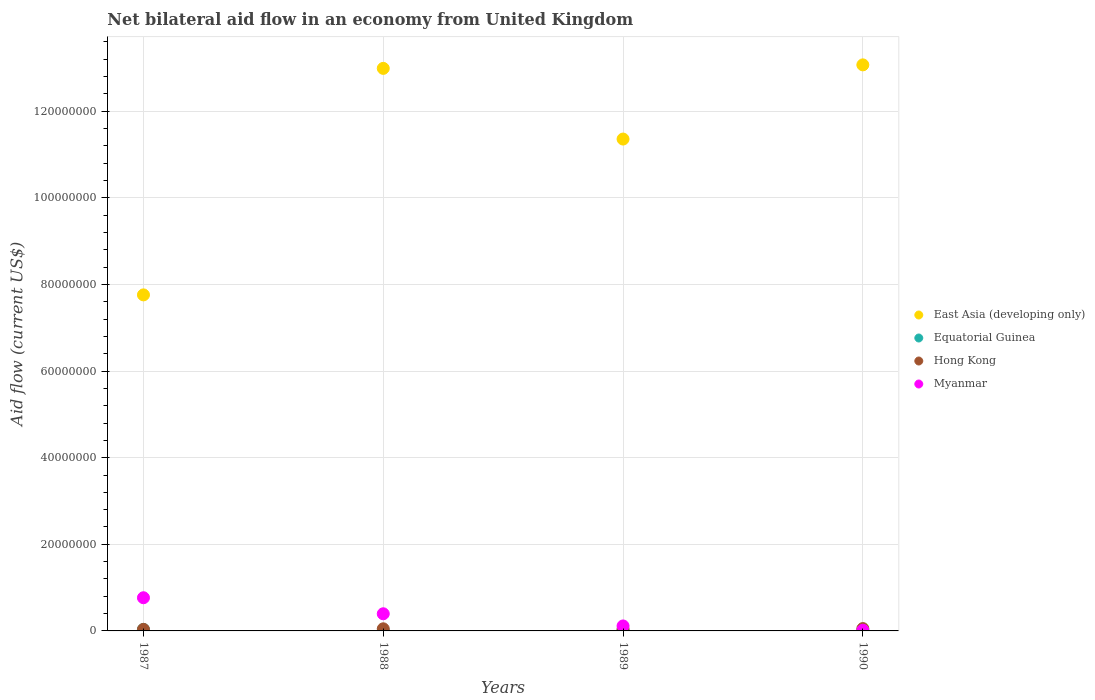How many different coloured dotlines are there?
Your answer should be compact. 4. Is the number of dotlines equal to the number of legend labels?
Ensure brevity in your answer.  Yes. What is the net bilateral aid flow in Hong Kong in 1988?
Provide a succinct answer. 4.90e+05. In which year was the net bilateral aid flow in Equatorial Guinea maximum?
Your answer should be very brief. 1987. In which year was the net bilateral aid flow in Myanmar minimum?
Your answer should be compact. 1990. What is the total net bilateral aid flow in Hong Kong in the graph?
Offer a terse response. 1.79e+06. What is the difference between the net bilateral aid flow in Hong Kong in 1988 and that in 1990?
Offer a very short reply. -5.00e+04. What is the difference between the net bilateral aid flow in Equatorial Guinea in 1989 and the net bilateral aid flow in Myanmar in 1987?
Offer a very short reply. -7.52e+06. What is the average net bilateral aid flow in Hong Kong per year?
Keep it short and to the point. 4.48e+05. In the year 1987, what is the difference between the net bilateral aid flow in Equatorial Guinea and net bilateral aid flow in East Asia (developing only)?
Provide a succinct answer. -7.72e+07. What is the ratio of the net bilateral aid flow in Hong Kong in 1987 to that in 1989?
Provide a succinct answer. 0.9. What is the difference between the highest and the lowest net bilateral aid flow in Myanmar?
Offer a terse response. 7.50e+06. Does the net bilateral aid flow in Myanmar monotonically increase over the years?
Your answer should be compact. No. Are the values on the major ticks of Y-axis written in scientific E-notation?
Your response must be concise. No. How are the legend labels stacked?
Keep it short and to the point. Vertical. What is the title of the graph?
Give a very brief answer. Net bilateral aid flow in an economy from United Kingdom. What is the label or title of the Y-axis?
Your answer should be compact. Aid flow (current US$). What is the Aid flow (current US$) in East Asia (developing only) in 1987?
Your answer should be compact. 7.76e+07. What is the Aid flow (current US$) of Hong Kong in 1987?
Your answer should be very brief. 3.60e+05. What is the Aid flow (current US$) of Myanmar in 1987?
Offer a terse response. 7.66e+06. What is the Aid flow (current US$) in East Asia (developing only) in 1988?
Offer a terse response. 1.30e+08. What is the Aid flow (current US$) of Myanmar in 1988?
Provide a succinct answer. 3.96e+06. What is the Aid flow (current US$) of East Asia (developing only) in 1989?
Your response must be concise. 1.14e+08. What is the Aid flow (current US$) in Hong Kong in 1989?
Provide a short and direct response. 4.00e+05. What is the Aid flow (current US$) of Myanmar in 1989?
Give a very brief answer. 1.15e+06. What is the Aid flow (current US$) in East Asia (developing only) in 1990?
Your response must be concise. 1.31e+08. What is the Aid flow (current US$) of Equatorial Guinea in 1990?
Keep it short and to the point. 9.00e+04. What is the Aid flow (current US$) in Hong Kong in 1990?
Offer a terse response. 5.40e+05. Across all years, what is the maximum Aid flow (current US$) in East Asia (developing only)?
Provide a succinct answer. 1.31e+08. Across all years, what is the maximum Aid flow (current US$) in Hong Kong?
Make the answer very short. 5.40e+05. Across all years, what is the maximum Aid flow (current US$) in Myanmar?
Offer a very short reply. 7.66e+06. Across all years, what is the minimum Aid flow (current US$) in East Asia (developing only)?
Give a very brief answer. 7.76e+07. Across all years, what is the minimum Aid flow (current US$) of Myanmar?
Your response must be concise. 1.60e+05. What is the total Aid flow (current US$) of East Asia (developing only) in the graph?
Offer a terse response. 4.52e+08. What is the total Aid flow (current US$) of Hong Kong in the graph?
Your answer should be compact. 1.79e+06. What is the total Aid flow (current US$) of Myanmar in the graph?
Keep it short and to the point. 1.29e+07. What is the difference between the Aid flow (current US$) in East Asia (developing only) in 1987 and that in 1988?
Your response must be concise. -5.23e+07. What is the difference between the Aid flow (current US$) of Equatorial Guinea in 1987 and that in 1988?
Provide a succinct answer. 3.10e+05. What is the difference between the Aid flow (current US$) of Myanmar in 1987 and that in 1988?
Your answer should be compact. 3.70e+06. What is the difference between the Aid flow (current US$) of East Asia (developing only) in 1987 and that in 1989?
Offer a very short reply. -3.60e+07. What is the difference between the Aid flow (current US$) of Equatorial Guinea in 1987 and that in 1989?
Make the answer very short. 2.00e+05. What is the difference between the Aid flow (current US$) in Myanmar in 1987 and that in 1989?
Give a very brief answer. 6.51e+06. What is the difference between the Aid flow (current US$) in East Asia (developing only) in 1987 and that in 1990?
Your answer should be compact. -5.31e+07. What is the difference between the Aid flow (current US$) of Equatorial Guinea in 1987 and that in 1990?
Your answer should be very brief. 2.50e+05. What is the difference between the Aid flow (current US$) of Hong Kong in 1987 and that in 1990?
Provide a succinct answer. -1.80e+05. What is the difference between the Aid flow (current US$) of Myanmar in 1987 and that in 1990?
Ensure brevity in your answer.  7.50e+06. What is the difference between the Aid flow (current US$) in East Asia (developing only) in 1988 and that in 1989?
Give a very brief answer. 1.63e+07. What is the difference between the Aid flow (current US$) of Equatorial Guinea in 1988 and that in 1989?
Give a very brief answer. -1.10e+05. What is the difference between the Aid flow (current US$) in Myanmar in 1988 and that in 1989?
Offer a very short reply. 2.81e+06. What is the difference between the Aid flow (current US$) in East Asia (developing only) in 1988 and that in 1990?
Ensure brevity in your answer.  -8.10e+05. What is the difference between the Aid flow (current US$) in Equatorial Guinea in 1988 and that in 1990?
Your answer should be very brief. -6.00e+04. What is the difference between the Aid flow (current US$) of Hong Kong in 1988 and that in 1990?
Ensure brevity in your answer.  -5.00e+04. What is the difference between the Aid flow (current US$) in Myanmar in 1988 and that in 1990?
Offer a terse response. 3.80e+06. What is the difference between the Aid flow (current US$) of East Asia (developing only) in 1989 and that in 1990?
Ensure brevity in your answer.  -1.71e+07. What is the difference between the Aid flow (current US$) in Equatorial Guinea in 1989 and that in 1990?
Offer a very short reply. 5.00e+04. What is the difference between the Aid flow (current US$) of Hong Kong in 1989 and that in 1990?
Your response must be concise. -1.40e+05. What is the difference between the Aid flow (current US$) of Myanmar in 1989 and that in 1990?
Your answer should be compact. 9.90e+05. What is the difference between the Aid flow (current US$) of East Asia (developing only) in 1987 and the Aid flow (current US$) of Equatorial Guinea in 1988?
Ensure brevity in your answer.  7.76e+07. What is the difference between the Aid flow (current US$) of East Asia (developing only) in 1987 and the Aid flow (current US$) of Hong Kong in 1988?
Provide a succinct answer. 7.71e+07. What is the difference between the Aid flow (current US$) in East Asia (developing only) in 1987 and the Aid flow (current US$) in Myanmar in 1988?
Offer a terse response. 7.36e+07. What is the difference between the Aid flow (current US$) in Equatorial Guinea in 1987 and the Aid flow (current US$) in Myanmar in 1988?
Make the answer very short. -3.62e+06. What is the difference between the Aid flow (current US$) of Hong Kong in 1987 and the Aid flow (current US$) of Myanmar in 1988?
Offer a terse response. -3.60e+06. What is the difference between the Aid flow (current US$) in East Asia (developing only) in 1987 and the Aid flow (current US$) in Equatorial Guinea in 1989?
Make the answer very short. 7.74e+07. What is the difference between the Aid flow (current US$) in East Asia (developing only) in 1987 and the Aid flow (current US$) in Hong Kong in 1989?
Keep it short and to the point. 7.72e+07. What is the difference between the Aid flow (current US$) in East Asia (developing only) in 1987 and the Aid flow (current US$) in Myanmar in 1989?
Offer a terse response. 7.64e+07. What is the difference between the Aid flow (current US$) in Equatorial Guinea in 1987 and the Aid flow (current US$) in Hong Kong in 1989?
Provide a short and direct response. -6.00e+04. What is the difference between the Aid flow (current US$) of Equatorial Guinea in 1987 and the Aid flow (current US$) of Myanmar in 1989?
Offer a terse response. -8.10e+05. What is the difference between the Aid flow (current US$) of Hong Kong in 1987 and the Aid flow (current US$) of Myanmar in 1989?
Offer a very short reply. -7.90e+05. What is the difference between the Aid flow (current US$) of East Asia (developing only) in 1987 and the Aid flow (current US$) of Equatorial Guinea in 1990?
Your response must be concise. 7.75e+07. What is the difference between the Aid flow (current US$) in East Asia (developing only) in 1987 and the Aid flow (current US$) in Hong Kong in 1990?
Make the answer very short. 7.70e+07. What is the difference between the Aid flow (current US$) in East Asia (developing only) in 1987 and the Aid flow (current US$) in Myanmar in 1990?
Your answer should be compact. 7.74e+07. What is the difference between the Aid flow (current US$) in East Asia (developing only) in 1988 and the Aid flow (current US$) in Equatorial Guinea in 1989?
Ensure brevity in your answer.  1.30e+08. What is the difference between the Aid flow (current US$) in East Asia (developing only) in 1988 and the Aid flow (current US$) in Hong Kong in 1989?
Your answer should be compact. 1.29e+08. What is the difference between the Aid flow (current US$) of East Asia (developing only) in 1988 and the Aid flow (current US$) of Myanmar in 1989?
Keep it short and to the point. 1.29e+08. What is the difference between the Aid flow (current US$) of Equatorial Guinea in 1988 and the Aid flow (current US$) of Hong Kong in 1989?
Keep it short and to the point. -3.70e+05. What is the difference between the Aid flow (current US$) of Equatorial Guinea in 1988 and the Aid flow (current US$) of Myanmar in 1989?
Keep it short and to the point. -1.12e+06. What is the difference between the Aid flow (current US$) in Hong Kong in 1988 and the Aid flow (current US$) in Myanmar in 1989?
Offer a terse response. -6.60e+05. What is the difference between the Aid flow (current US$) of East Asia (developing only) in 1988 and the Aid flow (current US$) of Equatorial Guinea in 1990?
Your answer should be very brief. 1.30e+08. What is the difference between the Aid flow (current US$) of East Asia (developing only) in 1988 and the Aid flow (current US$) of Hong Kong in 1990?
Provide a succinct answer. 1.29e+08. What is the difference between the Aid flow (current US$) in East Asia (developing only) in 1988 and the Aid flow (current US$) in Myanmar in 1990?
Offer a very short reply. 1.30e+08. What is the difference between the Aid flow (current US$) in Equatorial Guinea in 1988 and the Aid flow (current US$) in Hong Kong in 1990?
Offer a very short reply. -5.10e+05. What is the difference between the Aid flow (current US$) in Hong Kong in 1988 and the Aid flow (current US$) in Myanmar in 1990?
Keep it short and to the point. 3.30e+05. What is the difference between the Aid flow (current US$) in East Asia (developing only) in 1989 and the Aid flow (current US$) in Equatorial Guinea in 1990?
Make the answer very short. 1.13e+08. What is the difference between the Aid flow (current US$) in East Asia (developing only) in 1989 and the Aid flow (current US$) in Hong Kong in 1990?
Provide a short and direct response. 1.13e+08. What is the difference between the Aid flow (current US$) of East Asia (developing only) in 1989 and the Aid flow (current US$) of Myanmar in 1990?
Provide a short and direct response. 1.13e+08. What is the difference between the Aid flow (current US$) of Equatorial Guinea in 1989 and the Aid flow (current US$) of Hong Kong in 1990?
Your response must be concise. -4.00e+05. What is the difference between the Aid flow (current US$) in Hong Kong in 1989 and the Aid flow (current US$) in Myanmar in 1990?
Make the answer very short. 2.40e+05. What is the average Aid flow (current US$) in East Asia (developing only) per year?
Your answer should be very brief. 1.13e+08. What is the average Aid flow (current US$) of Hong Kong per year?
Offer a terse response. 4.48e+05. What is the average Aid flow (current US$) of Myanmar per year?
Ensure brevity in your answer.  3.23e+06. In the year 1987, what is the difference between the Aid flow (current US$) of East Asia (developing only) and Aid flow (current US$) of Equatorial Guinea?
Your response must be concise. 7.72e+07. In the year 1987, what is the difference between the Aid flow (current US$) in East Asia (developing only) and Aid flow (current US$) in Hong Kong?
Your answer should be compact. 7.72e+07. In the year 1987, what is the difference between the Aid flow (current US$) in East Asia (developing only) and Aid flow (current US$) in Myanmar?
Give a very brief answer. 6.99e+07. In the year 1987, what is the difference between the Aid flow (current US$) of Equatorial Guinea and Aid flow (current US$) of Hong Kong?
Provide a succinct answer. -2.00e+04. In the year 1987, what is the difference between the Aid flow (current US$) in Equatorial Guinea and Aid flow (current US$) in Myanmar?
Offer a very short reply. -7.32e+06. In the year 1987, what is the difference between the Aid flow (current US$) in Hong Kong and Aid flow (current US$) in Myanmar?
Keep it short and to the point. -7.30e+06. In the year 1988, what is the difference between the Aid flow (current US$) in East Asia (developing only) and Aid flow (current US$) in Equatorial Guinea?
Provide a short and direct response. 1.30e+08. In the year 1988, what is the difference between the Aid flow (current US$) in East Asia (developing only) and Aid flow (current US$) in Hong Kong?
Keep it short and to the point. 1.29e+08. In the year 1988, what is the difference between the Aid flow (current US$) of East Asia (developing only) and Aid flow (current US$) of Myanmar?
Ensure brevity in your answer.  1.26e+08. In the year 1988, what is the difference between the Aid flow (current US$) of Equatorial Guinea and Aid flow (current US$) of Hong Kong?
Offer a very short reply. -4.60e+05. In the year 1988, what is the difference between the Aid flow (current US$) of Equatorial Guinea and Aid flow (current US$) of Myanmar?
Make the answer very short. -3.93e+06. In the year 1988, what is the difference between the Aid flow (current US$) in Hong Kong and Aid flow (current US$) in Myanmar?
Your answer should be very brief. -3.47e+06. In the year 1989, what is the difference between the Aid flow (current US$) in East Asia (developing only) and Aid flow (current US$) in Equatorial Guinea?
Offer a very short reply. 1.13e+08. In the year 1989, what is the difference between the Aid flow (current US$) in East Asia (developing only) and Aid flow (current US$) in Hong Kong?
Offer a terse response. 1.13e+08. In the year 1989, what is the difference between the Aid flow (current US$) in East Asia (developing only) and Aid flow (current US$) in Myanmar?
Provide a succinct answer. 1.12e+08. In the year 1989, what is the difference between the Aid flow (current US$) of Equatorial Guinea and Aid flow (current US$) of Myanmar?
Provide a short and direct response. -1.01e+06. In the year 1989, what is the difference between the Aid flow (current US$) of Hong Kong and Aid flow (current US$) of Myanmar?
Your response must be concise. -7.50e+05. In the year 1990, what is the difference between the Aid flow (current US$) in East Asia (developing only) and Aid flow (current US$) in Equatorial Guinea?
Your answer should be very brief. 1.31e+08. In the year 1990, what is the difference between the Aid flow (current US$) in East Asia (developing only) and Aid flow (current US$) in Hong Kong?
Your answer should be compact. 1.30e+08. In the year 1990, what is the difference between the Aid flow (current US$) in East Asia (developing only) and Aid flow (current US$) in Myanmar?
Offer a very short reply. 1.31e+08. In the year 1990, what is the difference between the Aid flow (current US$) in Equatorial Guinea and Aid flow (current US$) in Hong Kong?
Keep it short and to the point. -4.50e+05. What is the ratio of the Aid flow (current US$) in East Asia (developing only) in 1987 to that in 1988?
Your answer should be very brief. 0.6. What is the ratio of the Aid flow (current US$) of Equatorial Guinea in 1987 to that in 1988?
Your response must be concise. 11.33. What is the ratio of the Aid flow (current US$) of Hong Kong in 1987 to that in 1988?
Give a very brief answer. 0.73. What is the ratio of the Aid flow (current US$) in Myanmar in 1987 to that in 1988?
Your answer should be compact. 1.93. What is the ratio of the Aid flow (current US$) in East Asia (developing only) in 1987 to that in 1989?
Offer a terse response. 0.68. What is the ratio of the Aid flow (current US$) in Equatorial Guinea in 1987 to that in 1989?
Provide a short and direct response. 2.43. What is the ratio of the Aid flow (current US$) in Hong Kong in 1987 to that in 1989?
Your answer should be very brief. 0.9. What is the ratio of the Aid flow (current US$) of Myanmar in 1987 to that in 1989?
Your answer should be compact. 6.66. What is the ratio of the Aid flow (current US$) in East Asia (developing only) in 1987 to that in 1990?
Your answer should be very brief. 0.59. What is the ratio of the Aid flow (current US$) in Equatorial Guinea in 1987 to that in 1990?
Ensure brevity in your answer.  3.78. What is the ratio of the Aid flow (current US$) of Hong Kong in 1987 to that in 1990?
Keep it short and to the point. 0.67. What is the ratio of the Aid flow (current US$) in Myanmar in 1987 to that in 1990?
Offer a very short reply. 47.88. What is the ratio of the Aid flow (current US$) in East Asia (developing only) in 1988 to that in 1989?
Keep it short and to the point. 1.14. What is the ratio of the Aid flow (current US$) in Equatorial Guinea in 1988 to that in 1989?
Your answer should be compact. 0.21. What is the ratio of the Aid flow (current US$) of Hong Kong in 1988 to that in 1989?
Give a very brief answer. 1.23. What is the ratio of the Aid flow (current US$) of Myanmar in 1988 to that in 1989?
Your answer should be compact. 3.44. What is the ratio of the Aid flow (current US$) of East Asia (developing only) in 1988 to that in 1990?
Provide a short and direct response. 0.99. What is the ratio of the Aid flow (current US$) of Equatorial Guinea in 1988 to that in 1990?
Give a very brief answer. 0.33. What is the ratio of the Aid flow (current US$) in Hong Kong in 1988 to that in 1990?
Make the answer very short. 0.91. What is the ratio of the Aid flow (current US$) of Myanmar in 1988 to that in 1990?
Give a very brief answer. 24.75. What is the ratio of the Aid flow (current US$) in East Asia (developing only) in 1989 to that in 1990?
Make the answer very short. 0.87. What is the ratio of the Aid flow (current US$) of Equatorial Guinea in 1989 to that in 1990?
Your answer should be compact. 1.56. What is the ratio of the Aid flow (current US$) of Hong Kong in 1989 to that in 1990?
Your answer should be very brief. 0.74. What is the ratio of the Aid flow (current US$) in Myanmar in 1989 to that in 1990?
Your answer should be compact. 7.19. What is the difference between the highest and the second highest Aid flow (current US$) in East Asia (developing only)?
Offer a terse response. 8.10e+05. What is the difference between the highest and the second highest Aid flow (current US$) in Equatorial Guinea?
Provide a short and direct response. 2.00e+05. What is the difference between the highest and the second highest Aid flow (current US$) in Hong Kong?
Your answer should be very brief. 5.00e+04. What is the difference between the highest and the second highest Aid flow (current US$) in Myanmar?
Provide a short and direct response. 3.70e+06. What is the difference between the highest and the lowest Aid flow (current US$) in East Asia (developing only)?
Make the answer very short. 5.31e+07. What is the difference between the highest and the lowest Aid flow (current US$) in Equatorial Guinea?
Provide a short and direct response. 3.10e+05. What is the difference between the highest and the lowest Aid flow (current US$) of Hong Kong?
Keep it short and to the point. 1.80e+05. What is the difference between the highest and the lowest Aid flow (current US$) of Myanmar?
Give a very brief answer. 7.50e+06. 